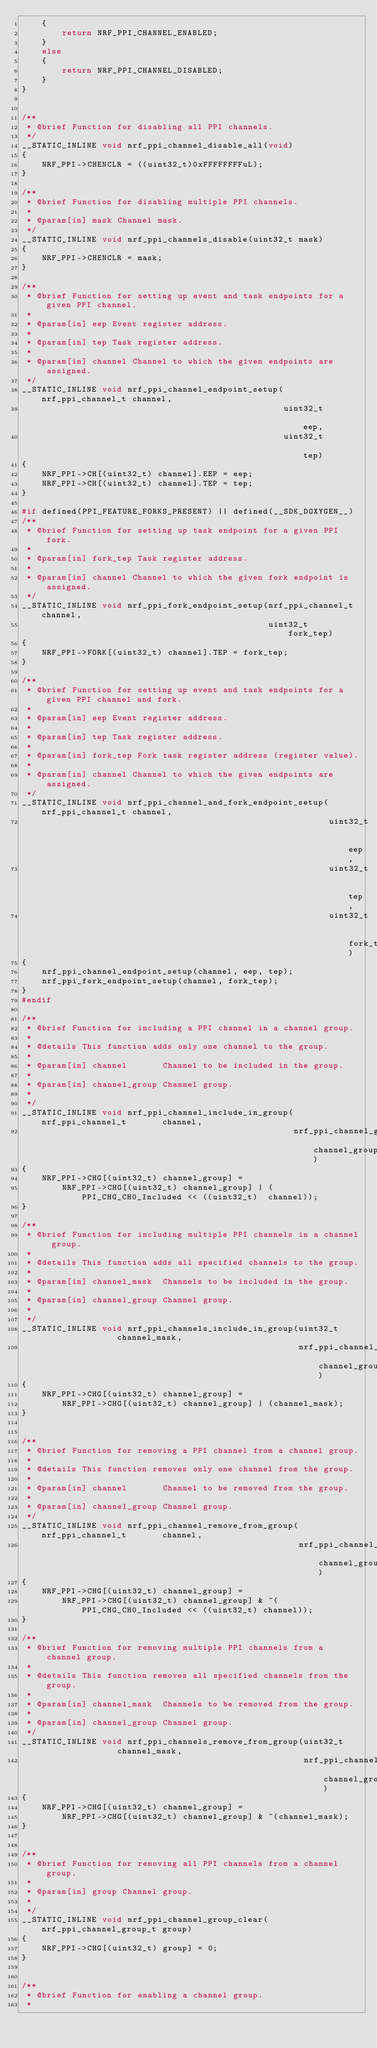Convert code to text. <code><loc_0><loc_0><loc_500><loc_500><_C_>    {
        return NRF_PPI_CHANNEL_ENABLED;
    }
    else
    {
        return NRF_PPI_CHANNEL_DISABLED;
    }
}


/**
 * @brief Function for disabling all PPI channels.
 */
__STATIC_INLINE void nrf_ppi_channel_disable_all(void)
{
    NRF_PPI->CHENCLR = ((uint32_t)0xFFFFFFFFuL);
}

/**
 * @brief Function for disabling multiple PPI channels.
 *
 * @param[in] mask Channel mask.
 */
__STATIC_INLINE void nrf_ppi_channels_disable(uint32_t mask)
{
    NRF_PPI->CHENCLR = mask;
}

/**
 * @brief Function for setting up event and task endpoints for a given PPI channel.
 *
 * @param[in] eep Event register address.
 *
 * @param[in] tep Task register address.
 *
 * @param[in] channel Channel to which the given endpoints are assigned.
 */
__STATIC_INLINE void nrf_ppi_channel_endpoint_setup(nrf_ppi_channel_t channel,
                                                    uint32_t          eep,
                                                    uint32_t          tep)
{
    NRF_PPI->CH[(uint32_t) channel].EEP = eep;
    NRF_PPI->CH[(uint32_t) channel].TEP = tep;
}

#if defined(PPI_FEATURE_FORKS_PRESENT) || defined(__SDK_DOXYGEN__)
/**
 * @brief Function for setting up task endpoint for a given PPI fork.
 *
 * @param[in] fork_tep Task register address.
 *
 * @param[in] channel Channel to which the given fork endpoint is assigned.
 */
__STATIC_INLINE void nrf_ppi_fork_endpoint_setup(nrf_ppi_channel_t channel,
                                                 uint32_t          fork_tep)
{
    NRF_PPI->FORK[(uint32_t) channel].TEP = fork_tep;
}

/**
 * @brief Function for setting up event and task endpoints for a given PPI channel and fork.
 *
 * @param[in] eep Event register address.
 *
 * @param[in] tep Task register address.
 *
 * @param[in] fork_tep Fork task register address (register value).
 *
 * @param[in] channel Channel to which the given endpoints are assigned.
 */
__STATIC_INLINE void nrf_ppi_channel_and_fork_endpoint_setup(nrf_ppi_channel_t channel,
                                                             uint32_t          eep,
                                                             uint32_t          tep,
                                                             uint32_t          fork_tep)
{
    nrf_ppi_channel_endpoint_setup(channel, eep, tep);
    nrf_ppi_fork_endpoint_setup(channel, fork_tep);
}
#endif

/**
 * @brief Function for including a PPI channel in a channel group.
 *
 * @details This function adds only one channel to the group.
 *
 * @param[in] channel       Channel to be included in the group.
 *
 * @param[in] channel_group Channel group.
 *
 */
__STATIC_INLINE void nrf_ppi_channel_include_in_group(nrf_ppi_channel_t       channel,
                                                      nrf_ppi_channel_group_t channel_group)
{
    NRF_PPI->CHG[(uint32_t) channel_group] =
        NRF_PPI->CHG[(uint32_t) channel_group] | (PPI_CHG_CH0_Included << ((uint32_t)  channel));
}

/**
 * @brief Function for including multiple PPI channels in a channel group.
 *
 * @details This function adds all specified channels to the group.
 *
 * @param[in] channel_mask  Channels to be included in the group.
 *
 * @param[in] channel_group Channel group.
 *
 */
__STATIC_INLINE void nrf_ppi_channels_include_in_group(uint32_t                channel_mask,
                                                       nrf_ppi_channel_group_t channel_group)
{
    NRF_PPI->CHG[(uint32_t) channel_group] =
        NRF_PPI->CHG[(uint32_t) channel_group] | (channel_mask);
}


/**
 * @brief Function for removing a PPI channel from a channel group.
 *
 * @details This function removes only one channel from the group.
 *
 * @param[in] channel       Channel to be removed from the group.
 *
 * @param[in] channel_group Channel group.
 */
__STATIC_INLINE void nrf_ppi_channel_remove_from_group(nrf_ppi_channel_t       channel,
                                                       nrf_ppi_channel_group_t channel_group)
{
    NRF_PPI->CHG[(uint32_t) channel_group] =
        NRF_PPI->CHG[(uint32_t) channel_group] & ~(PPI_CHG_CH0_Included << ((uint32_t) channel));
}

/**
 * @brief Function for removing multiple PPI channels from a channel group.
 *
 * @details This function removes all specified channels from the group.
 *
 * @param[in] channel_mask  Channels to be removed from the group.
 *
 * @param[in] channel_group Channel group.
 */
__STATIC_INLINE void nrf_ppi_channels_remove_from_group(uint32_t                channel_mask,
                                                        nrf_ppi_channel_group_t channel_group)
{
    NRF_PPI->CHG[(uint32_t) channel_group] =
        NRF_PPI->CHG[(uint32_t) channel_group] & ~(channel_mask);
}


/**
 * @brief Function for removing all PPI channels from a channel group.
 *
 * @param[in] group Channel group.
 *
 */
__STATIC_INLINE void nrf_ppi_channel_group_clear(nrf_ppi_channel_group_t group)
{
    NRF_PPI->CHG[(uint32_t) group] = 0;
}


/**
 * @brief Function for enabling a channel group.
 *</code> 